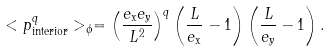<formula> <loc_0><loc_0><loc_500><loc_500>< p _ { \text {interior} } ^ { q } > _ { \phi } = \left ( \frac { e _ { \text {x} } e _ { \text {y} } } { L ^ { 2 } } \right ) ^ { q } \left ( \frac { L } { e _ { \text {x} } } - 1 \right ) \left ( \frac { L } { e _ { \text {y} } } - 1 \right ) .</formula> 